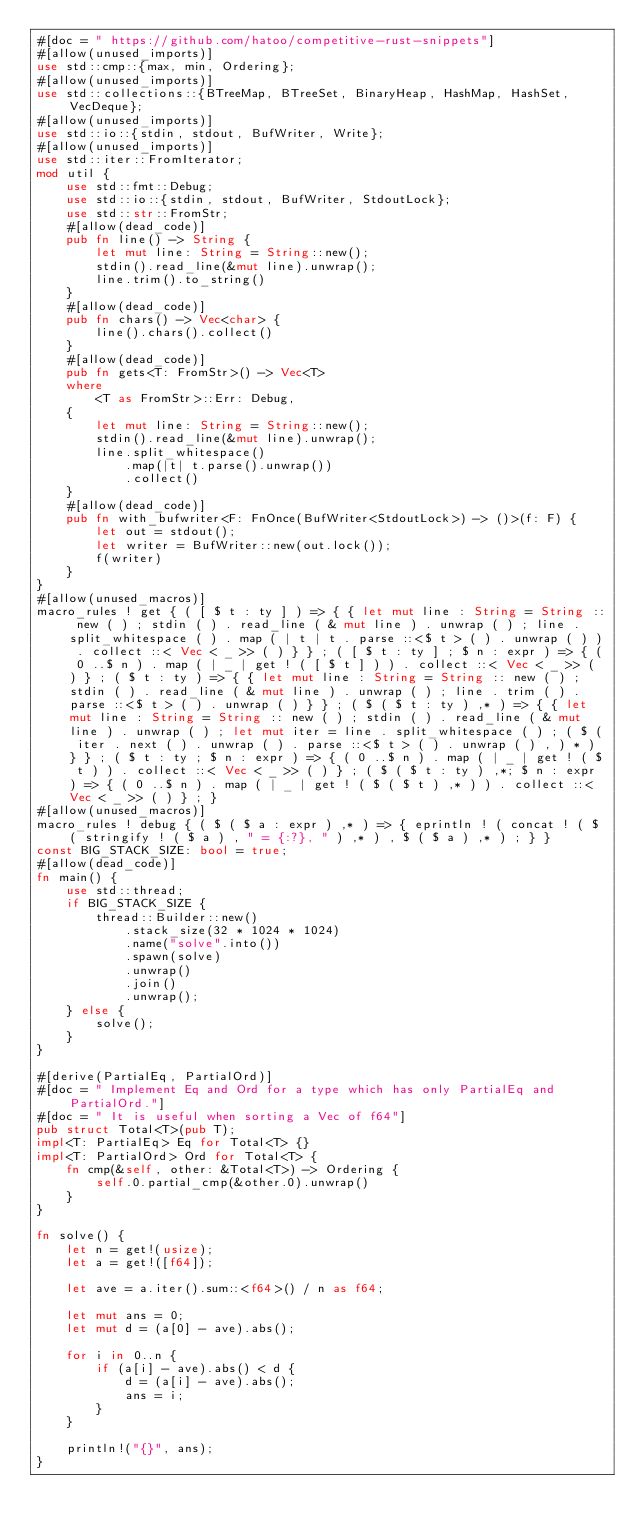Convert code to text. <code><loc_0><loc_0><loc_500><loc_500><_Rust_>#[doc = " https://github.com/hatoo/competitive-rust-snippets"]
#[allow(unused_imports)]
use std::cmp::{max, min, Ordering};
#[allow(unused_imports)]
use std::collections::{BTreeMap, BTreeSet, BinaryHeap, HashMap, HashSet, VecDeque};
#[allow(unused_imports)]
use std::io::{stdin, stdout, BufWriter, Write};
#[allow(unused_imports)]
use std::iter::FromIterator;
mod util {
    use std::fmt::Debug;
    use std::io::{stdin, stdout, BufWriter, StdoutLock};
    use std::str::FromStr;
    #[allow(dead_code)]
    pub fn line() -> String {
        let mut line: String = String::new();
        stdin().read_line(&mut line).unwrap();
        line.trim().to_string()
    }
    #[allow(dead_code)]
    pub fn chars() -> Vec<char> {
        line().chars().collect()
    }
    #[allow(dead_code)]
    pub fn gets<T: FromStr>() -> Vec<T>
    where
        <T as FromStr>::Err: Debug,
    {
        let mut line: String = String::new();
        stdin().read_line(&mut line).unwrap();
        line.split_whitespace()
            .map(|t| t.parse().unwrap())
            .collect()
    }
    #[allow(dead_code)]
    pub fn with_bufwriter<F: FnOnce(BufWriter<StdoutLock>) -> ()>(f: F) {
        let out = stdout();
        let writer = BufWriter::new(out.lock());
        f(writer)
    }
}
#[allow(unused_macros)]
macro_rules ! get { ( [ $ t : ty ] ) => { { let mut line : String = String :: new ( ) ; stdin ( ) . read_line ( & mut line ) . unwrap ( ) ; line . split_whitespace ( ) . map ( | t | t . parse ::<$ t > ( ) . unwrap ( ) ) . collect ::< Vec < _ >> ( ) } } ; ( [ $ t : ty ] ; $ n : expr ) => { ( 0 ..$ n ) . map ( | _ | get ! ( [ $ t ] ) ) . collect ::< Vec < _ >> ( ) } ; ( $ t : ty ) => { { let mut line : String = String :: new ( ) ; stdin ( ) . read_line ( & mut line ) . unwrap ( ) ; line . trim ( ) . parse ::<$ t > ( ) . unwrap ( ) } } ; ( $ ( $ t : ty ) ,* ) => { { let mut line : String = String :: new ( ) ; stdin ( ) . read_line ( & mut line ) . unwrap ( ) ; let mut iter = line . split_whitespace ( ) ; ( $ ( iter . next ( ) . unwrap ( ) . parse ::<$ t > ( ) . unwrap ( ) , ) * ) } } ; ( $ t : ty ; $ n : expr ) => { ( 0 ..$ n ) . map ( | _ | get ! ( $ t ) ) . collect ::< Vec < _ >> ( ) } ; ( $ ( $ t : ty ) ,*; $ n : expr ) => { ( 0 ..$ n ) . map ( | _ | get ! ( $ ( $ t ) ,* ) ) . collect ::< Vec < _ >> ( ) } ; }
#[allow(unused_macros)]
macro_rules ! debug { ( $ ( $ a : expr ) ,* ) => { eprintln ! ( concat ! ( $ ( stringify ! ( $ a ) , " = {:?}, " ) ,* ) , $ ( $ a ) ,* ) ; } }
const BIG_STACK_SIZE: bool = true;
#[allow(dead_code)]
fn main() {
    use std::thread;
    if BIG_STACK_SIZE {
        thread::Builder::new()
            .stack_size(32 * 1024 * 1024)
            .name("solve".into())
            .spawn(solve)
            .unwrap()
            .join()
            .unwrap();
    } else {
        solve();
    }
}

#[derive(PartialEq, PartialOrd)]
#[doc = " Implement Eq and Ord for a type which has only PartialEq and PartialOrd."]
#[doc = " It is useful when sorting a Vec of f64"]
pub struct Total<T>(pub T);
impl<T: PartialEq> Eq for Total<T> {}
impl<T: PartialOrd> Ord for Total<T> {
    fn cmp(&self, other: &Total<T>) -> Ordering {
        self.0.partial_cmp(&other.0).unwrap()
    }
}

fn solve() {
    let n = get!(usize);
    let a = get!([f64]);

    let ave = a.iter().sum::<f64>() / n as f64;

    let mut ans = 0;
    let mut d = (a[0] - ave).abs();

    for i in 0..n {
        if (a[i] - ave).abs() < d {
            d = (a[i] - ave).abs();
            ans = i;
        }
    }

    println!("{}", ans);
}
</code> 